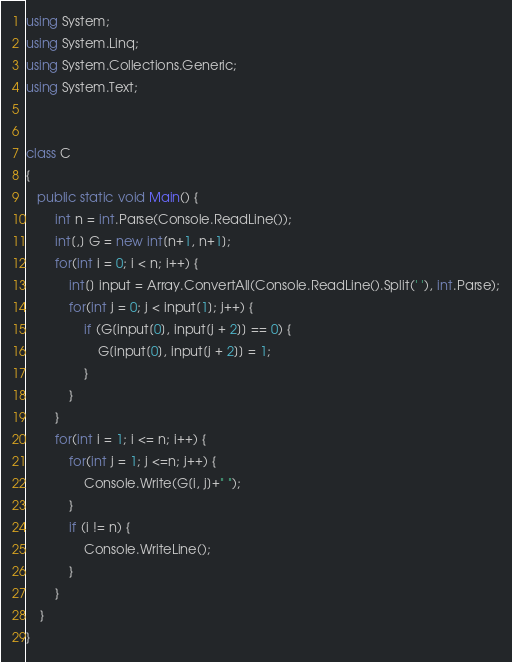<code> <loc_0><loc_0><loc_500><loc_500><_C#_>using System;
using System.Linq;
using System.Collections.Generic;
using System.Text;


class C
{
   public static void Main() {
        int n = int.Parse(Console.ReadLine());
        int[,] G = new int[n+1, n+1];
        for(int i = 0; i < n; i++) {
            int[] input = Array.ConvertAll(Console.ReadLine().Split(' '), int.Parse);
            for(int j = 0; j < input[1]; j++) {
                if (G[input[0], input[j + 2]] == 0) {
                    G[input[0], input[j + 2]] = 1;
                }
            }
        }
        for(int i = 1; i <= n; i++) {
            for(int j = 1; j <=n; j++) {
                Console.Write(G[i, j]+" ");
            }
            if (i != n) {
                Console.WriteLine();
            }
        }
    }
}
</code> 